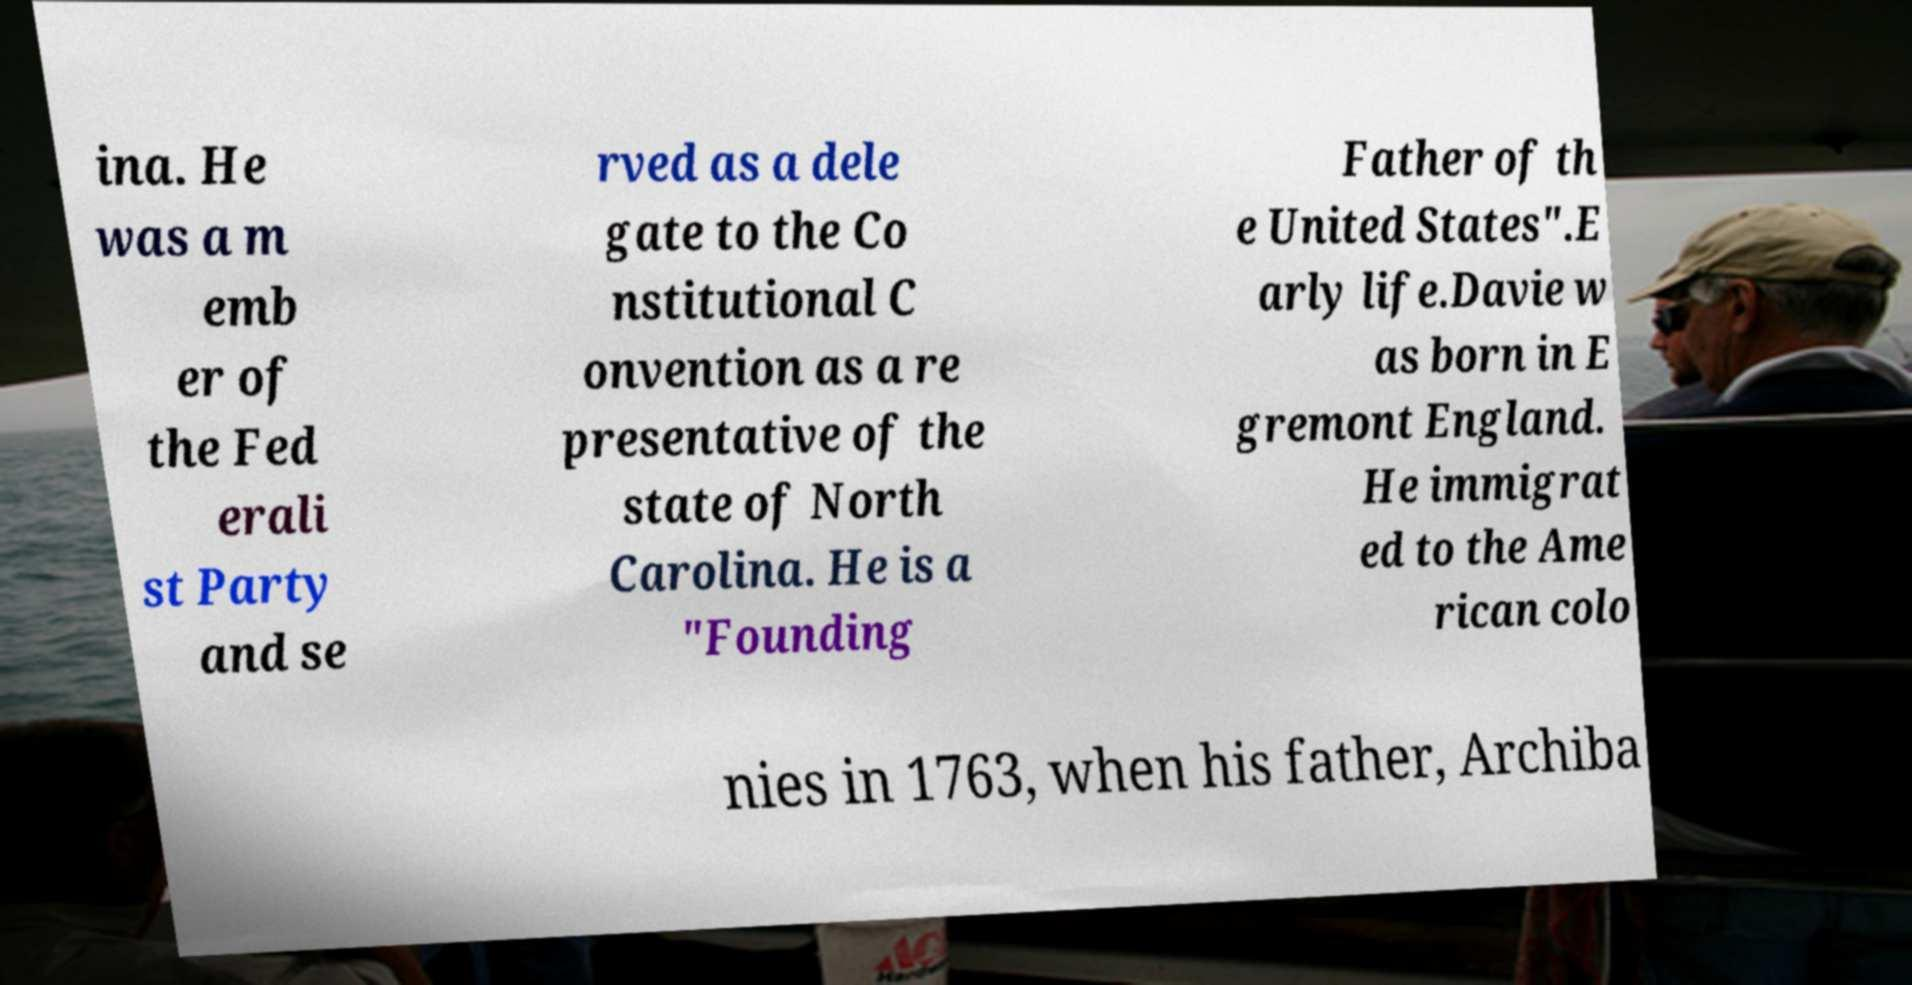I need the written content from this picture converted into text. Can you do that? ina. He was a m emb er of the Fed erali st Party and se rved as a dele gate to the Co nstitutional C onvention as a re presentative of the state of North Carolina. He is a "Founding Father of th e United States".E arly life.Davie w as born in E gremont England. He immigrat ed to the Ame rican colo nies in 1763, when his father, Archiba 